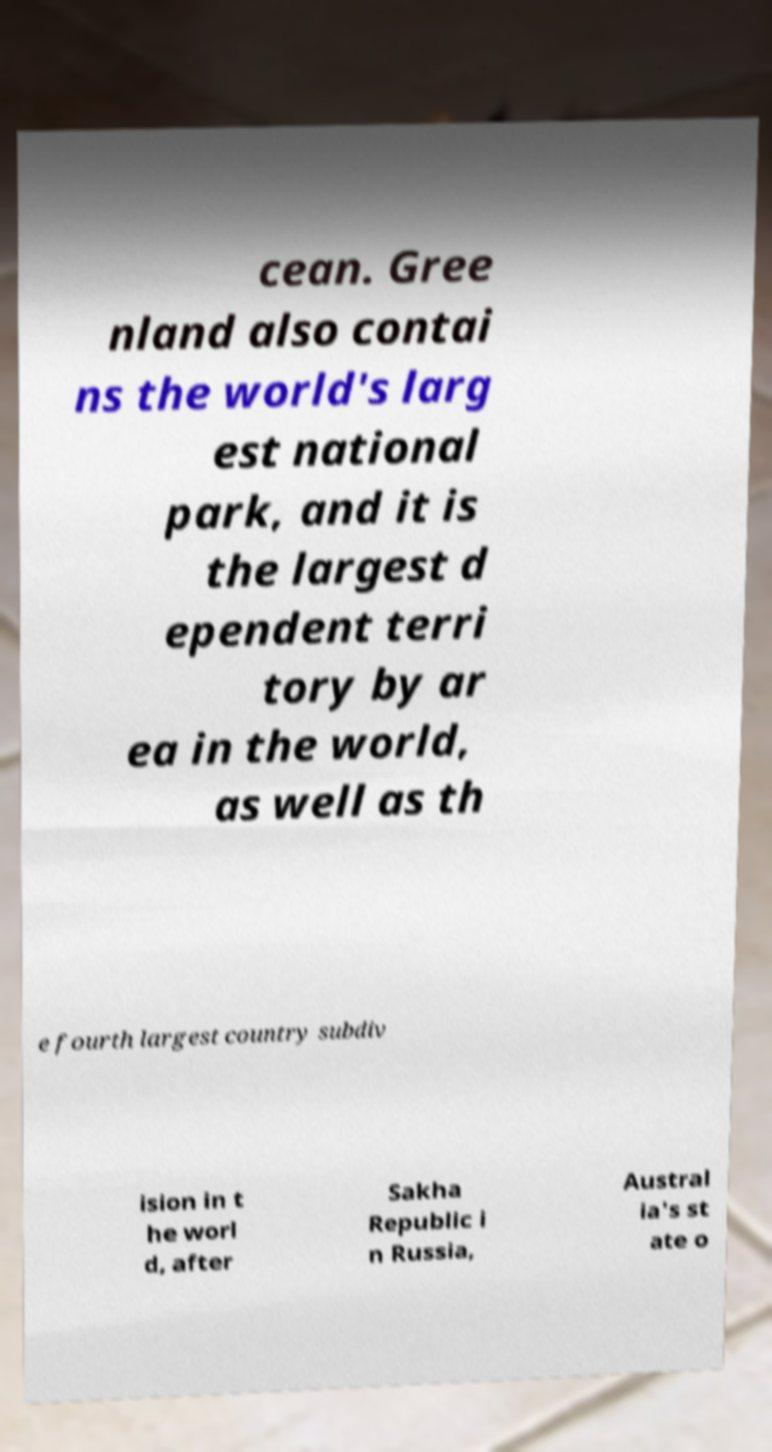Can you accurately transcribe the text from the provided image for me? cean. Gree nland also contai ns the world's larg est national park, and it is the largest d ependent terri tory by ar ea in the world, as well as th e fourth largest country subdiv ision in t he worl d, after Sakha Republic i n Russia, Austral ia's st ate o 